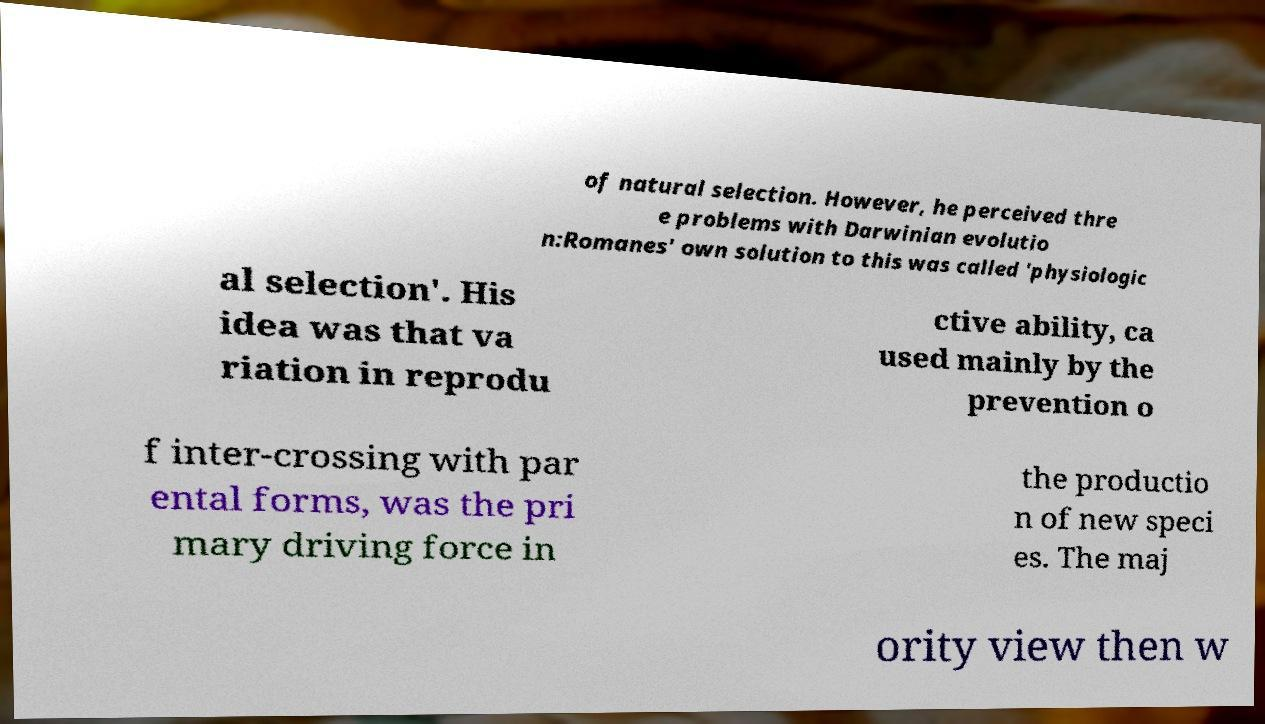I need the written content from this picture converted into text. Can you do that? of natural selection. However, he perceived thre e problems with Darwinian evolutio n:Romanes' own solution to this was called 'physiologic al selection'. His idea was that va riation in reprodu ctive ability, ca used mainly by the prevention o f inter-crossing with par ental forms, was the pri mary driving force in the productio n of new speci es. The maj ority view then w 